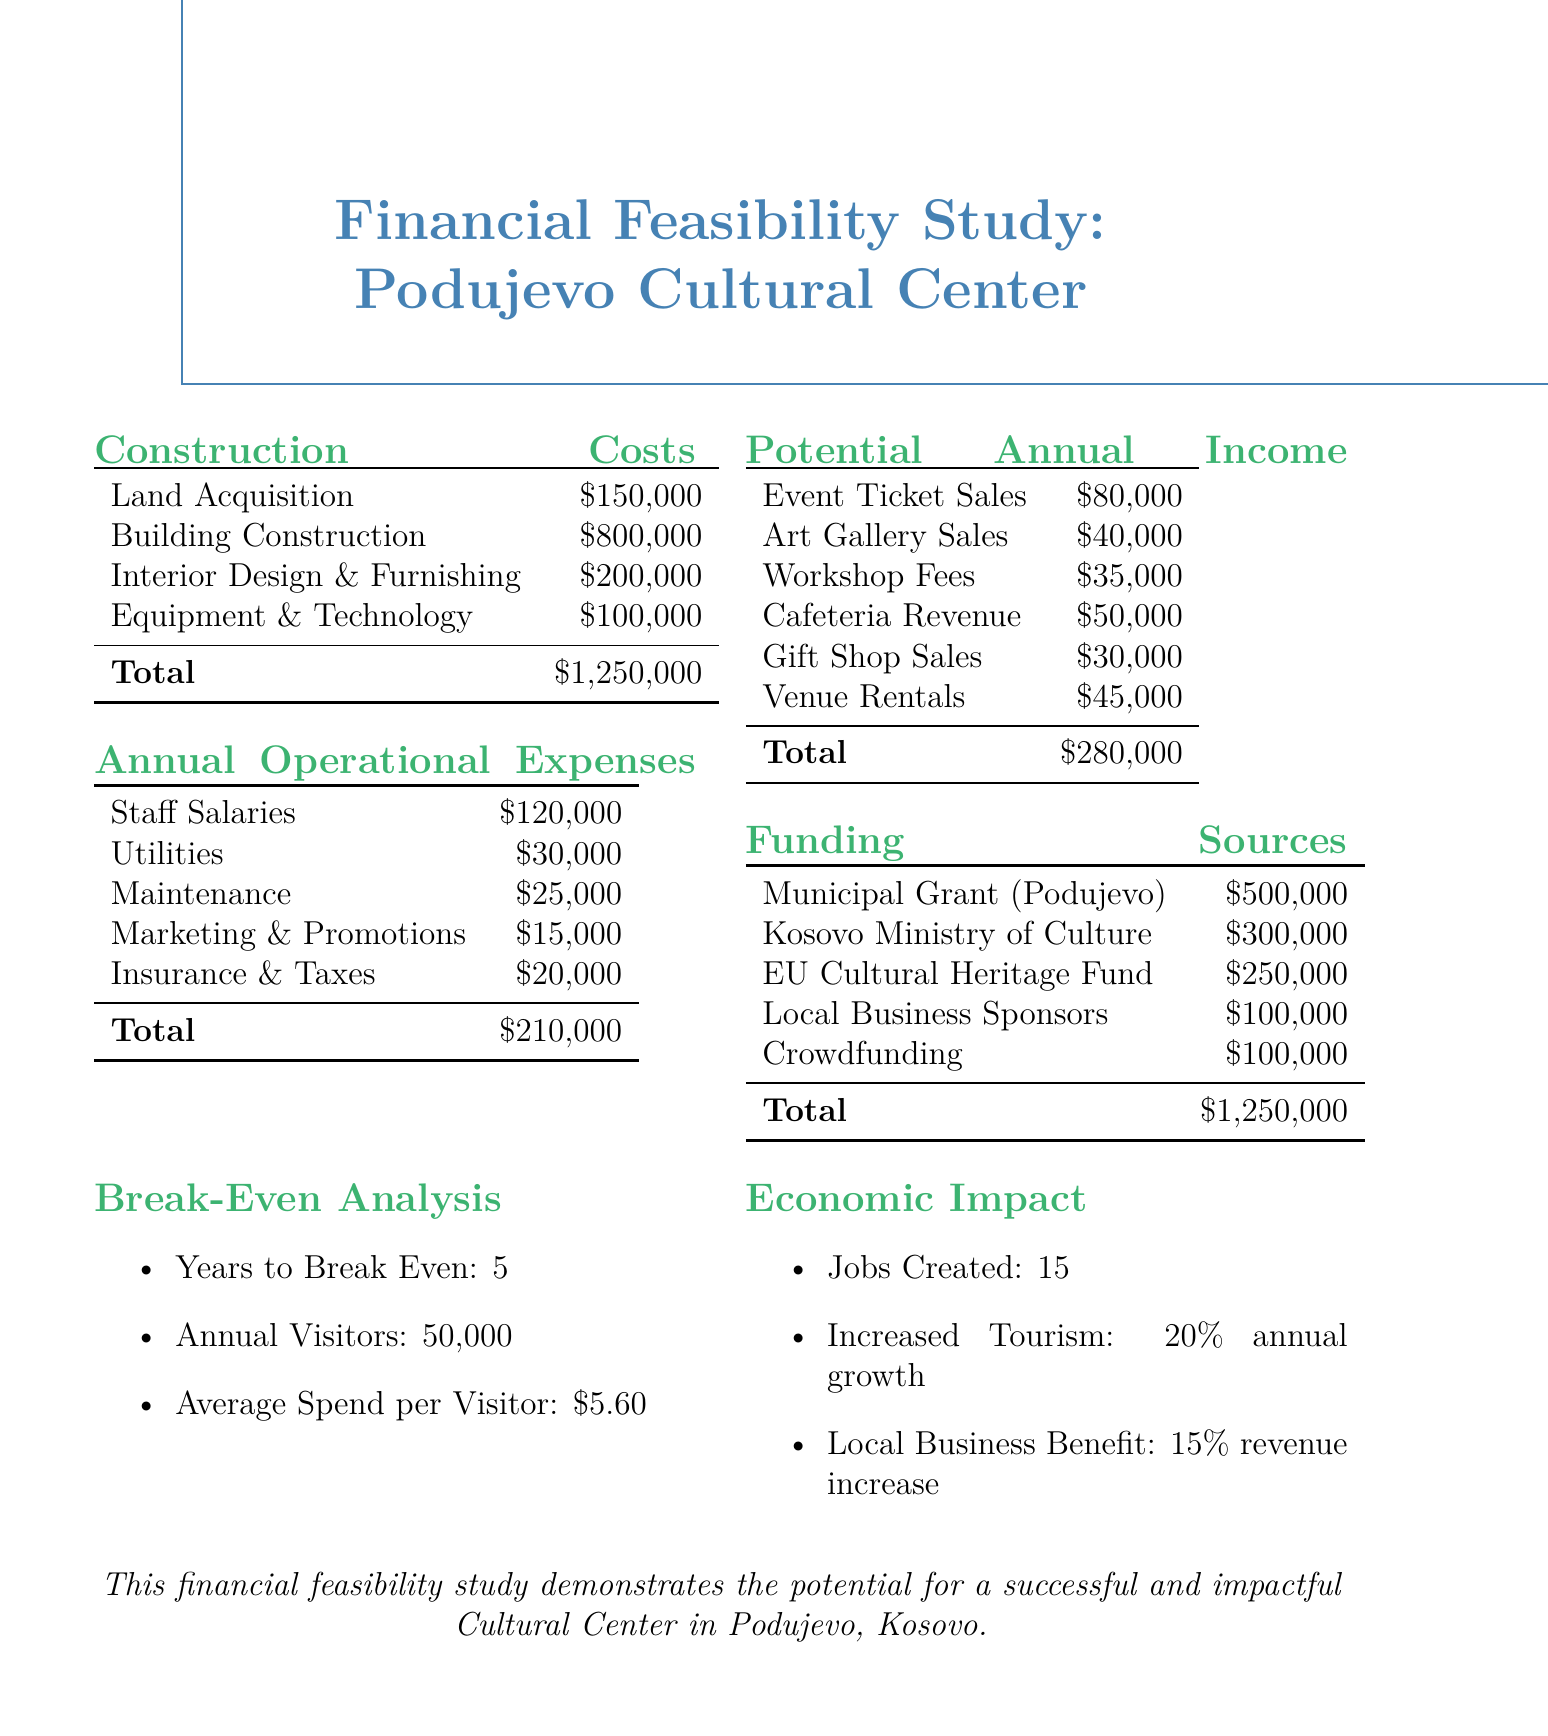what is the total construction cost? The total construction cost is presented at the end of the construction costs section, which sums up all individual costs.
Answer: $1,250,000 what is the total annual operational expenses? The total annual operational expenses are listed after summing up all the operational costs provided in the document.
Answer: $210,000 how many jobs will be created? The number of jobs created is outlined in the economic impact section, discussing the positive outcomes of the cultural center.
Answer: 15 what is the funding source from the Municipal Grant Podujevo? This funding source shows the amount allocated specifically for municipal support within the project's funding section.
Answer: $500,000 how many years are needed to break even? The break-even analysis highlights the time frame required for the project to become self-sustaining.
Answer: 5 what is the average spend per visitor? The average spend per visitor is mentioned in the break-even analysis, indicating how much each visitor would contribute.
Answer: $5.60 what percentage increase in tourism is expected annually? The economic impact section clearly states the expected yearly growth in tourism as part of the cultural center's benefits.
Answer: 20% what is the total income from event ticket sales? This figure represents one of the potential income streams listed in the document, detailing earnings from ticket sales.
Answer: $80,000 what is the total amount from local business sponsors? The local business sponsors’ contribution is noted within the funding sources, indicating the financial support from businesses.
Answer: $100,000 